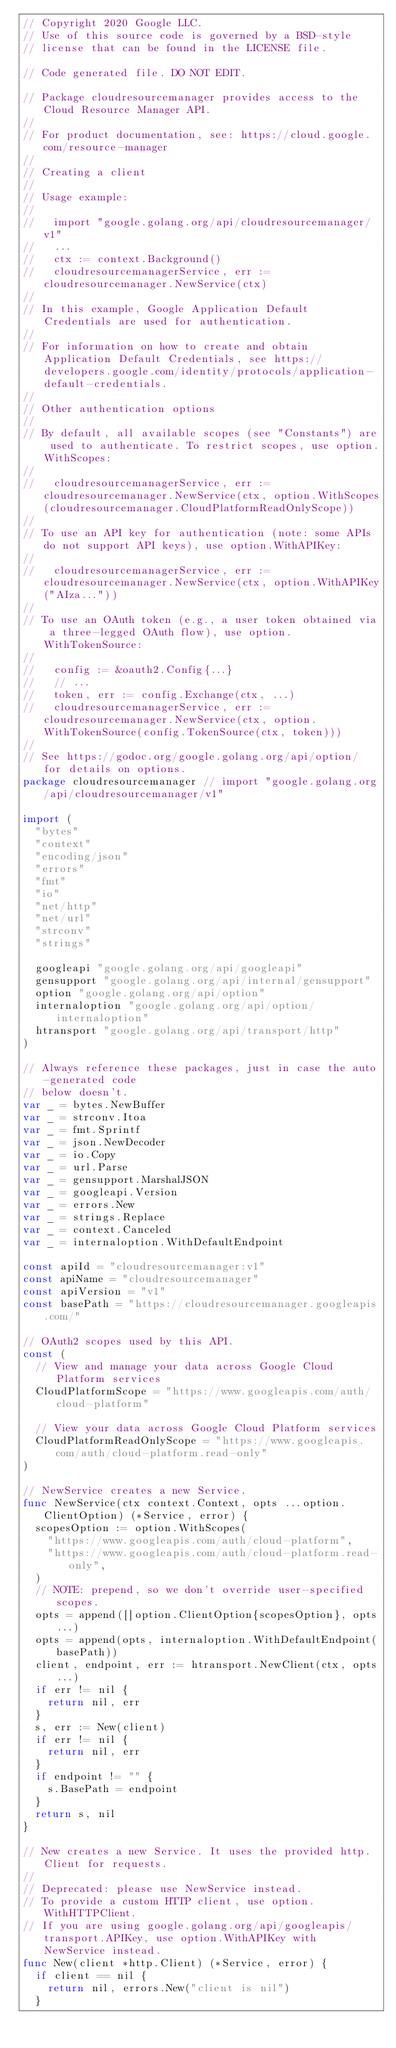Convert code to text. <code><loc_0><loc_0><loc_500><loc_500><_Go_>// Copyright 2020 Google LLC.
// Use of this source code is governed by a BSD-style
// license that can be found in the LICENSE file.

// Code generated file. DO NOT EDIT.

// Package cloudresourcemanager provides access to the Cloud Resource Manager API.
//
// For product documentation, see: https://cloud.google.com/resource-manager
//
// Creating a client
//
// Usage example:
//
//   import "google.golang.org/api/cloudresourcemanager/v1"
//   ...
//   ctx := context.Background()
//   cloudresourcemanagerService, err := cloudresourcemanager.NewService(ctx)
//
// In this example, Google Application Default Credentials are used for authentication.
//
// For information on how to create and obtain Application Default Credentials, see https://developers.google.com/identity/protocols/application-default-credentials.
//
// Other authentication options
//
// By default, all available scopes (see "Constants") are used to authenticate. To restrict scopes, use option.WithScopes:
//
//   cloudresourcemanagerService, err := cloudresourcemanager.NewService(ctx, option.WithScopes(cloudresourcemanager.CloudPlatformReadOnlyScope))
//
// To use an API key for authentication (note: some APIs do not support API keys), use option.WithAPIKey:
//
//   cloudresourcemanagerService, err := cloudresourcemanager.NewService(ctx, option.WithAPIKey("AIza..."))
//
// To use an OAuth token (e.g., a user token obtained via a three-legged OAuth flow), use option.WithTokenSource:
//
//   config := &oauth2.Config{...}
//   // ...
//   token, err := config.Exchange(ctx, ...)
//   cloudresourcemanagerService, err := cloudresourcemanager.NewService(ctx, option.WithTokenSource(config.TokenSource(ctx, token)))
//
// See https://godoc.org/google.golang.org/api/option/ for details on options.
package cloudresourcemanager // import "google.golang.org/api/cloudresourcemanager/v1"

import (
	"bytes"
	"context"
	"encoding/json"
	"errors"
	"fmt"
	"io"
	"net/http"
	"net/url"
	"strconv"
	"strings"

	googleapi "google.golang.org/api/googleapi"
	gensupport "google.golang.org/api/internal/gensupport"
	option "google.golang.org/api/option"
	internaloption "google.golang.org/api/option/internaloption"
	htransport "google.golang.org/api/transport/http"
)

// Always reference these packages, just in case the auto-generated code
// below doesn't.
var _ = bytes.NewBuffer
var _ = strconv.Itoa
var _ = fmt.Sprintf
var _ = json.NewDecoder
var _ = io.Copy
var _ = url.Parse
var _ = gensupport.MarshalJSON
var _ = googleapi.Version
var _ = errors.New
var _ = strings.Replace
var _ = context.Canceled
var _ = internaloption.WithDefaultEndpoint

const apiId = "cloudresourcemanager:v1"
const apiName = "cloudresourcemanager"
const apiVersion = "v1"
const basePath = "https://cloudresourcemanager.googleapis.com/"

// OAuth2 scopes used by this API.
const (
	// View and manage your data across Google Cloud Platform services
	CloudPlatformScope = "https://www.googleapis.com/auth/cloud-platform"

	// View your data across Google Cloud Platform services
	CloudPlatformReadOnlyScope = "https://www.googleapis.com/auth/cloud-platform.read-only"
)

// NewService creates a new Service.
func NewService(ctx context.Context, opts ...option.ClientOption) (*Service, error) {
	scopesOption := option.WithScopes(
		"https://www.googleapis.com/auth/cloud-platform",
		"https://www.googleapis.com/auth/cloud-platform.read-only",
	)
	// NOTE: prepend, so we don't override user-specified scopes.
	opts = append([]option.ClientOption{scopesOption}, opts...)
	opts = append(opts, internaloption.WithDefaultEndpoint(basePath))
	client, endpoint, err := htransport.NewClient(ctx, opts...)
	if err != nil {
		return nil, err
	}
	s, err := New(client)
	if err != nil {
		return nil, err
	}
	if endpoint != "" {
		s.BasePath = endpoint
	}
	return s, nil
}

// New creates a new Service. It uses the provided http.Client for requests.
//
// Deprecated: please use NewService instead.
// To provide a custom HTTP client, use option.WithHTTPClient.
// If you are using google.golang.org/api/googleapis/transport.APIKey, use option.WithAPIKey with NewService instead.
func New(client *http.Client) (*Service, error) {
	if client == nil {
		return nil, errors.New("client is nil")
	}</code> 